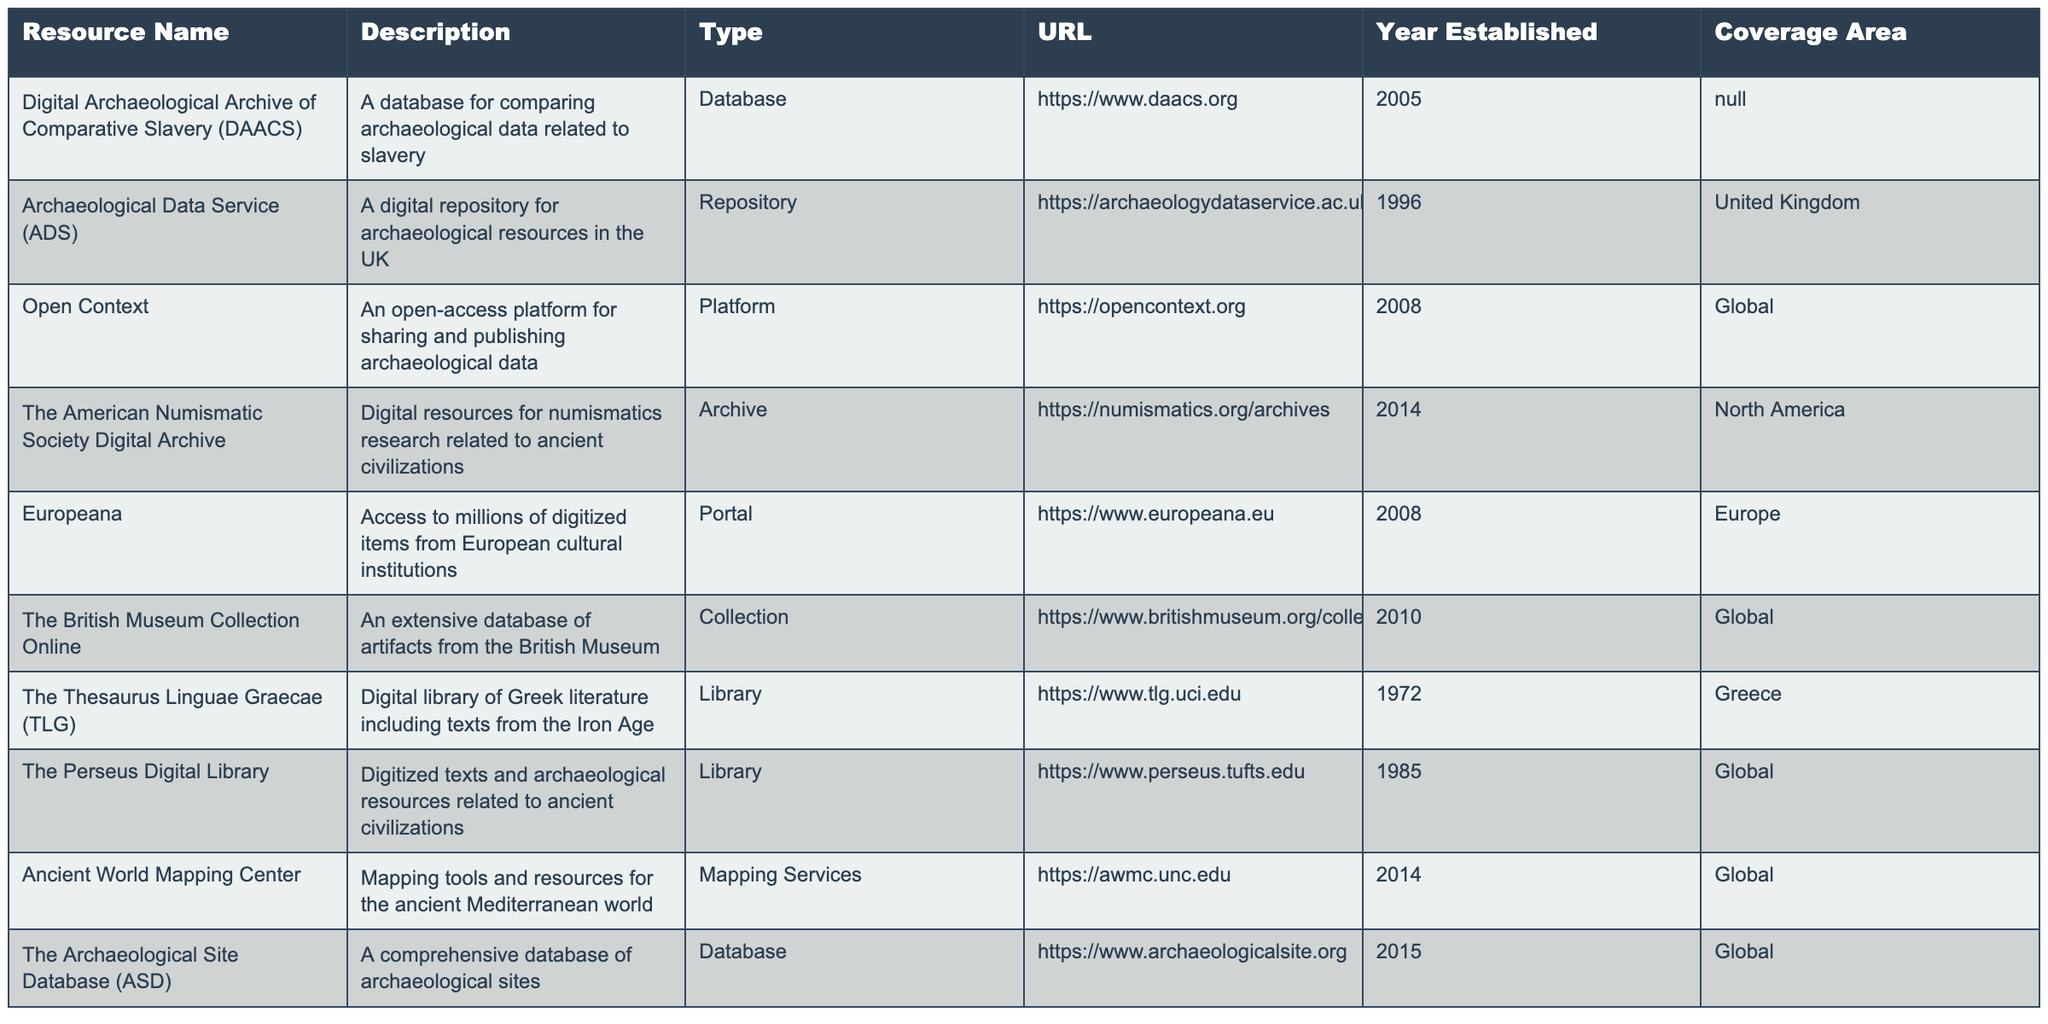What is the URL for the Archaeological Data Service? The table shows that the URL for the Archaeological Data Service is listed in its respective row as https://archaeologydataservice.ac.uk.
Answer: https://archaeologydataservice.ac.uk Which resource was established first? To determine which resource was established first, we can look at the "Year Established" column. The earliest year listed is 1972 for The Thesaurus Linguae Graecae.
Answer: The Thesaurus Linguae Graecae How many resources are focused on global coverage? By checking the "Coverage Area" column for the mention of "Global", we can count the resources. There are 5 resources (Open Context, The British Museum Collection Online, The Perseus Digital Library, Ancient World Mapping Center, and The Archaeological Site Database) that cover a global area.
Answer: 5 Is the Digital Archaeological Archive of Comparative Slavery focused on European resources? The table indicates that the Digital Archaeological Archive of Comparative Slavery has a coverage area listed as "N/A", meaning it does not specifically focus on European resources.
Answer: No Which resource provides mapping tools specifically for the ancient Mediterranean world? The "Mapping Services" type in the table identifies that the Ancient World Mapping Center offers mapping tools specifically for the ancient Mediterranean world.
Answer: Ancient World Mapping Center What is the difference between the years established for the American Numismatic Society Digital Archive and the Digital Archaeological Archive of Comparative Slavery? The American Numismatic Society Digital Archive was established in 2014, and the Digital Archaeological Archive of Comparative Slavery was established in 2005. The difference is 2014 - 2005 = 9 years.
Answer: 9 years Does the British Museum Collection Online provide resources for numismatics research? The table does not list the British Museum Collection Online as providing resources for numismatics research; instead, that resource is specified for the American Numismatic Society Digital Archive.
Answer: No Which database covers archaeological sites and was established most recently? The table shows The Archaeological Site Database was established in 2015, the most recent year listed for any database covering archaeological sites.
Answer: The Archaeological Site Database 